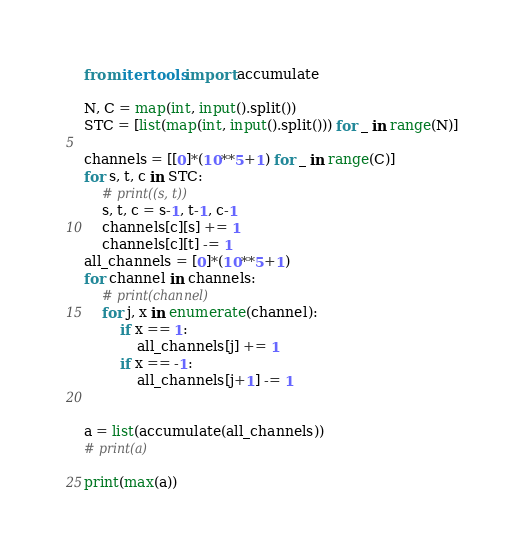Convert code to text. <code><loc_0><loc_0><loc_500><loc_500><_Python_>from itertools import accumulate

N, C = map(int, input().split())
STC = [list(map(int, input().split())) for _ in range(N)]

channels = [[0]*(10**5+1) for _ in range(C)]
for s, t, c in STC:
    # print((s, t))
    s, t, c = s-1, t-1, c-1
    channels[c][s] += 1
    channels[c][t] -= 1
all_channels = [0]*(10**5+1)
for channel in channels:
    # print(channel)
    for j, x in enumerate(channel):
        if x == 1:
            all_channels[j] += 1
        if x == -1:
            all_channels[j+1] -= 1 


a = list(accumulate(all_channels))
# print(a)

print(max(a))</code> 